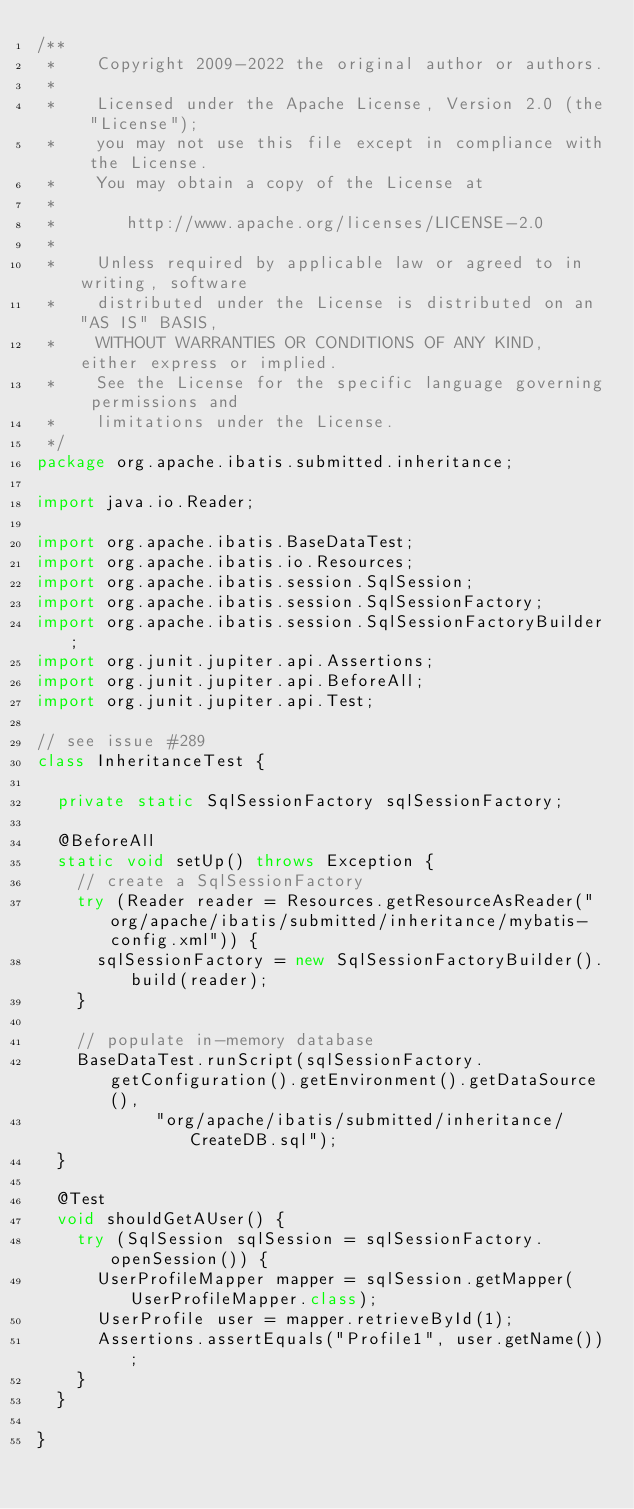Convert code to text. <code><loc_0><loc_0><loc_500><loc_500><_Java_>/**
 *    Copyright 2009-2022 the original author or authors.
 *
 *    Licensed under the Apache License, Version 2.0 (the "License");
 *    you may not use this file except in compliance with the License.
 *    You may obtain a copy of the License at
 *
 *       http://www.apache.org/licenses/LICENSE-2.0
 *
 *    Unless required by applicable law or agreed to in writing, software
 *    distributed under the License is distributed on an "AS IS" BASIS,
 *    WITHOUT WARRANTIES OR CONDITIONS OF ANY KIND, either express or implied.
 *    See the License for the specific language governing permissions and
 *    limitations under the License.
 */
package org.apache.ibatis.submitted.inheritance;

import java.io.Reader;

import org.apache.ibatis.BaseDataTest;
import org.apache.ibatis.io.Resources;
import org.apache.ibatis.session.SqlSession;
import org.apache.ibatis.session.SqlSessionFactory;
import org.apache.ibatis.session.SqlSessionFactoryBuilder;
import org.junit.jupiter.api.Assertions;
import org.junit.jupiter.api.BeforeAll;
import org.junit.jupiter.api.Test;

// see issue #289
class InheritanceTest {

  private static SqlSessionFactory sqlSessionFactory;

  @BeforeAll
  static void setUp() throws Exception {
    // create a SqlSessionFactory
    try (Reader reader = Resources.getResourceAsReader("org/apache/ibatis/submitted/inheritance/mybatis-config.xml")) {
      sqlSessionFactory = new SqlSessionFactoryBuilder().build(reader);
    }

    // populate in-memory database
    BaseDataTest.runScript(sqlSessionFactory.getConfiguration().getEnvironment().getDataSource(),
            "org/apache/ibatis/submitted/inheritance/CreateDB.sql");
  }

  @Test
  void shouldGetAUser() {
    try (SqlSession sqlSession = sqlSessionFactory.openSession()) {
      UserProfileMapper mapper = sqlSession.getMapper(UserProfileMapper.class);
      UserProfile user = mapper.retrieveById(1);
      Assertions.assertEquals("Profile1", user.getName());
    }
  }

}
</code> 